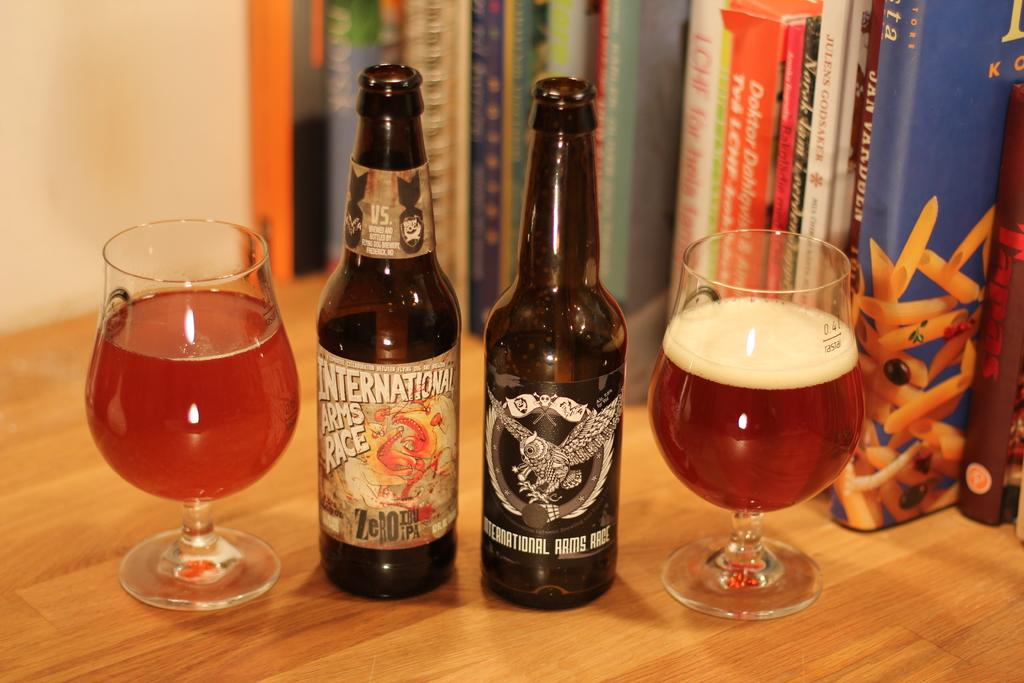<image>
Provide a brief description of the given image. A bottle of International Arms Race sits next to a different bottle of beer. 